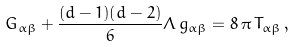<formula> <loc_0><loc_0><loc_500><loc_500>G _ { \alpha \beta } + \frac { ( d - 1 ) ( d - 2 ) } { 6 } \Lambda \, g _ { \alpha \beta } = 8 \, \pi \, T _ { \alpha \beta } \, ,</formula> 